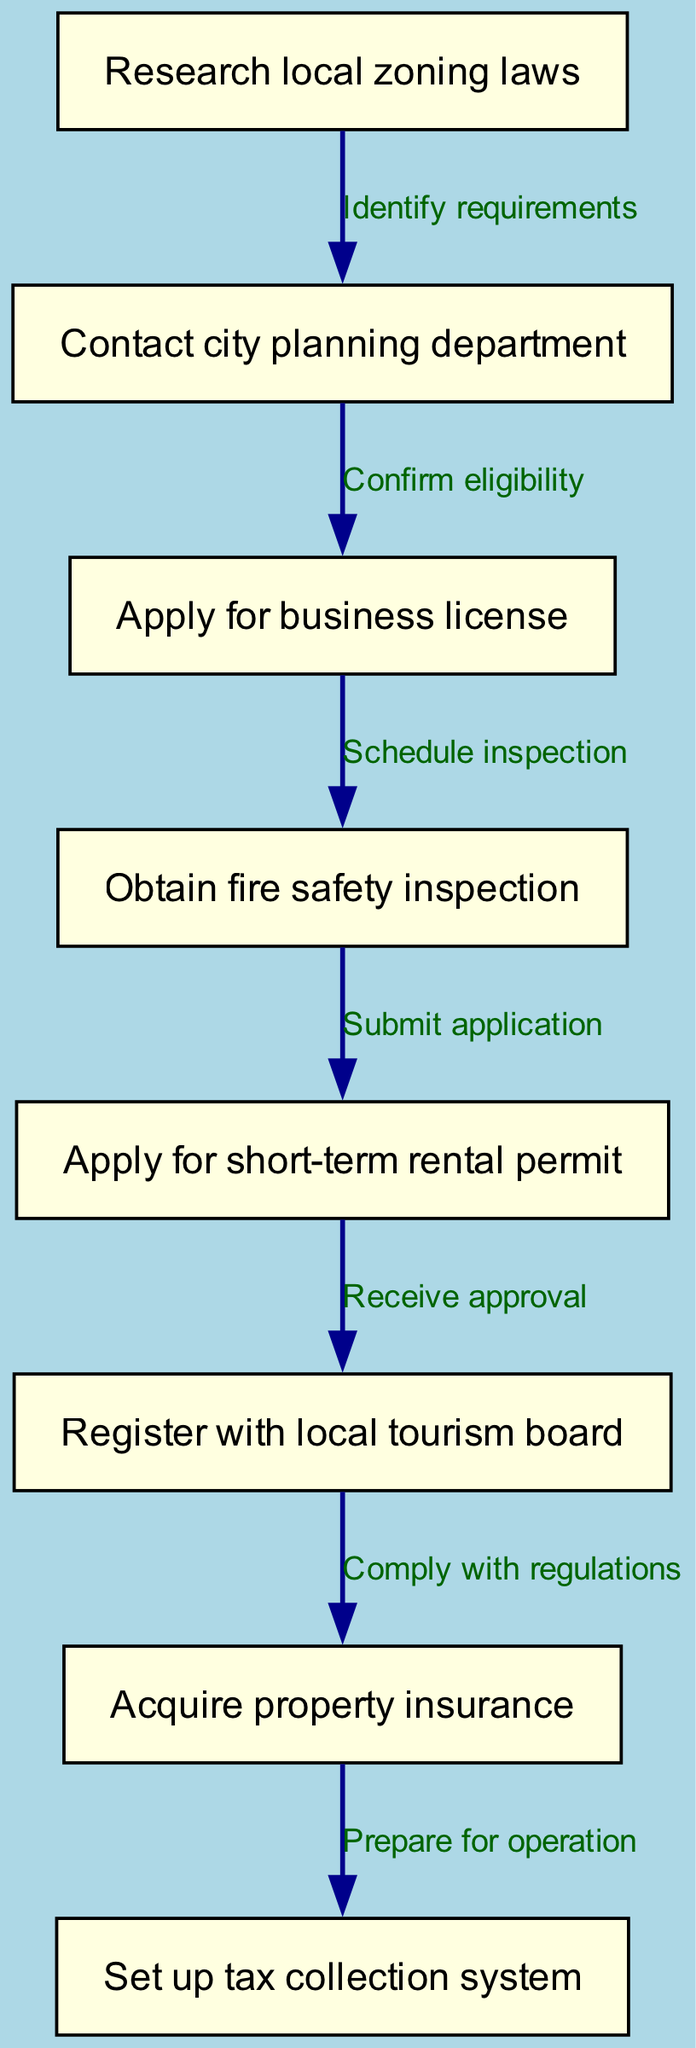What is the first step in the workflow? The first step, as indicated in the diagram, is "Research local zoning laws." This is the initial node and the starting point of the workflow.
Answer: Research local zoning laws How many nodes are in the diagram? By counting the nodes listed in the diagram, there are a total of eight nodes that represent different steps in the permit and license acquisition process.
Answer: 8 What step comes after obtaining fire safety inspection? The step that follows "Obtain fire safety inspection" is "Apply for short-term rental permit," indicating the next part of the procedure after the inspection is completed.
Answer: Apply for short-term rental permit What is the connection between "Contact city planning department" and "Apply for business license"? The relationship between these two nodes is described by the phrase "Confirm eligibility," indicating that after contacting the planning department, confirming eligibility is necessary to proceed with the business license application.
Answer: Confirm eligibility What must be completed before registering with the local tourism board? Before registering with the local tourism board, the step "Apply for short-term rental permit" must be completed and followed by receiving approval. This establishes the requirement that must be satisfied beforehand.
Answer: Apply for short-term rental permit What type of inspection is required in the workflow? The workflow specifies that a "fire safety inspection" is required, which is a critical step in ensuring compliance with safety regulations before moving on to the next steps.
Answer: fire safety inspection Which node involves the preparation for operation? The last node in the workflow that signifies the preparation for operation is "Set up tax collection system," which follows acquiring property insurance, wrapping up the permit and license process.
Answer: Set up tax collection system What do you need to do after complying with regulations? After complying with regulations, the next necessary action is to "Acquire property insurance," which is crucial for protecting the investment in the vacation rental.
Answer: Acquire property insurance 